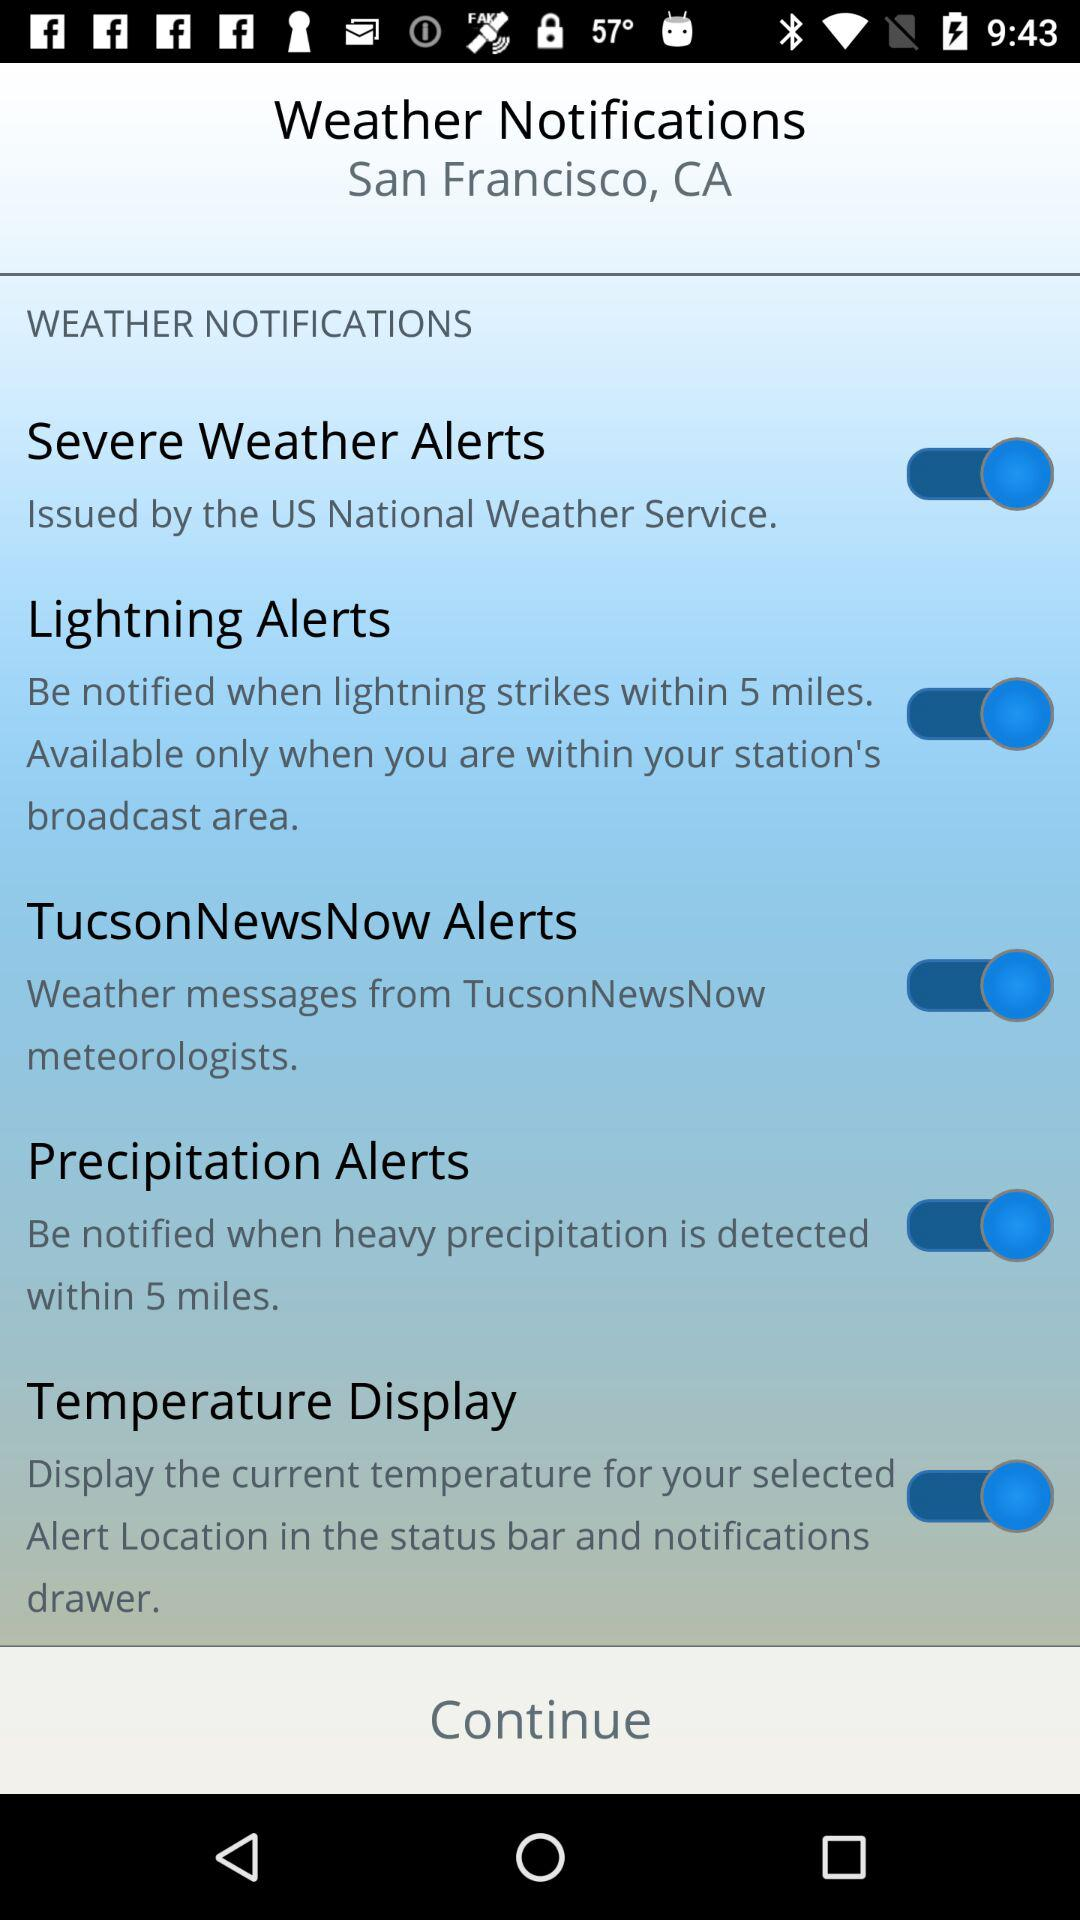Within how many miles will I be notified if precipitation is detected? You will be notified within 5 miles. 